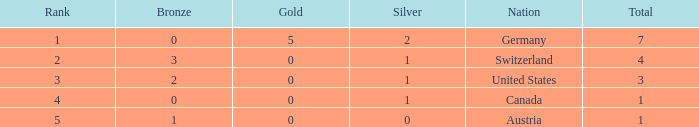What is the total number of bronze when the total is less than 1? None. 